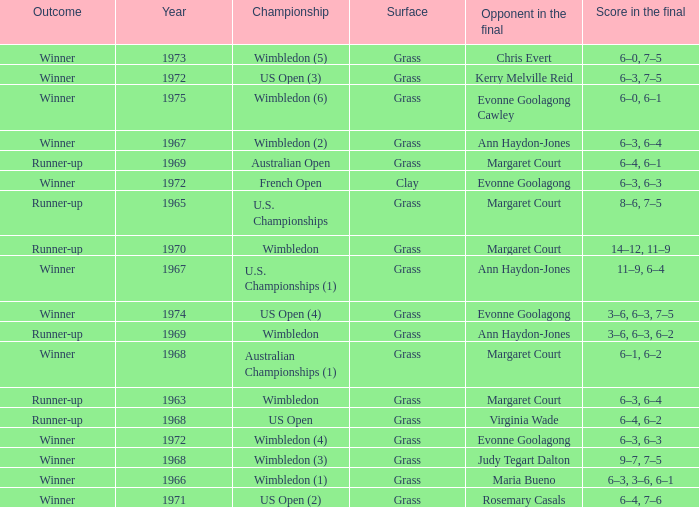What was the final score of the Australian Open? 6–4, 6–1. 